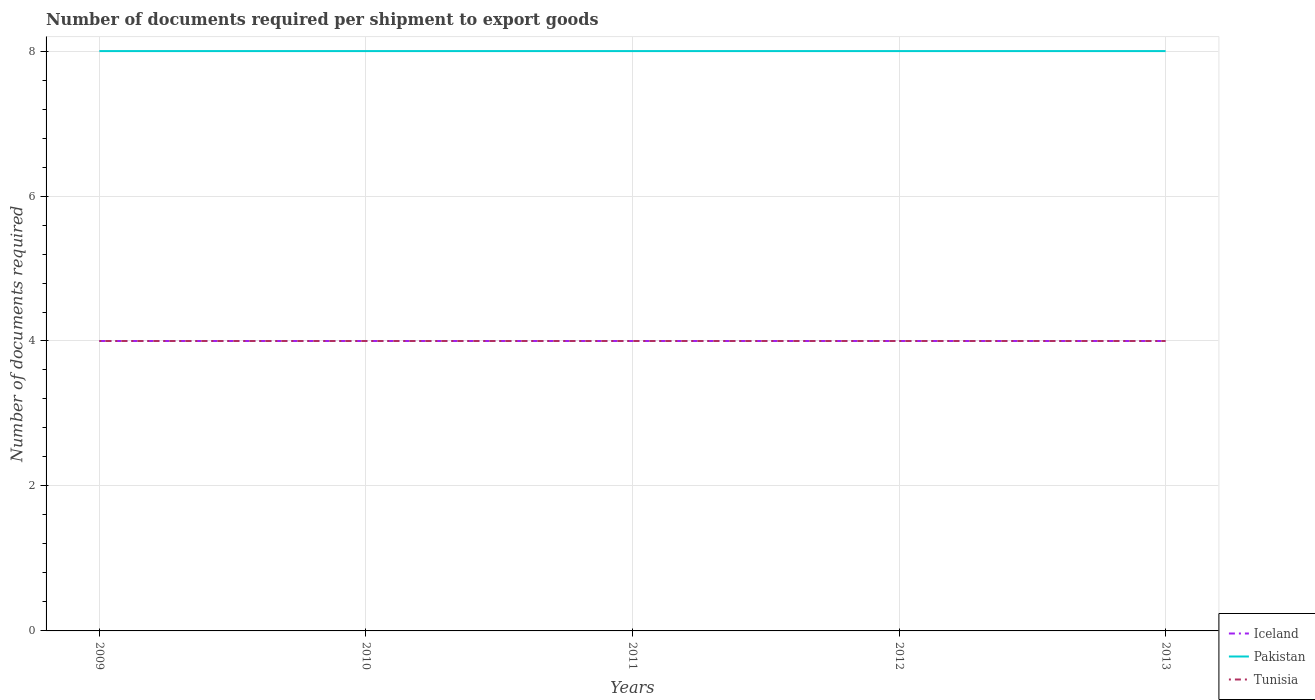How many different coloured lines are there?
Provide a succinct answer. 3. Across all years, what is the maximum number of documents required per shipment to export goods in Tunisia?
Offer a very short reply. 4. What is the difference between the highest and the second highest number of documents required per shipment to export goods in Pakistan?
Provide a succinct answer. 0. What is the difference between the highest and the lowest number of documents required per shipment to export goods in Tunisia?
Keep it short and to the point. 0. How many legend labels are there?
Make the answer very short. 3. How are the legend labels stacked?
Ensure brevity in your answer.  Vertical. What is the title of the graph?
Keep it short and to the point. Number of documents required per shipment to export goods. What is the label or title of the X-axis?
Your answer should be very brief. Years. What is the label or title of the Y-axis?
Provide a short and direct response. Number of documents required. What is the Number of documents required of Tunisia in 2009?
Provide a short and direct response. 4. What is the Number of documents required of Iceland in 2010?
Provide a succinct answer. 4. What is the Number of documents required of Pakistan in 2010?
Your answer should be compact. 8. What is the Number of documents required of Tunisia in 2010?
Ensure brevity in your answer.  4. What is the Number of documents required of Iceland in 2011?
Offer a terse response. 4. What is the Number of documents required of Pakistan in 2012?
Provide a succinct answer. 8. What is the Number of documents required in Tunisia in 2012?
Provide a short and direct response. 4. What is the Number of documents required of Tunisia in 2013?
Your answer should be compact. 4. Across all years, what is the maximum Number of documents required of Tunisia?
Offer a very short reply. 4. What is the difference between the Number of documents required of Iceland in 2009 and that in 2010?
Your response must be concise. 0. What is the difference between the Number of documents required in Pakistan in 2009 and that in 2010?
Your response must be concise. 0. What is the difference between the Number of documents required of Tunisia in 2009 and that in 2010?
Make the answer very short. 0. What is the difference between the Number of documents required in Pakistan in 2009 and that in 2012?
Offer a terse response. 0. What is the difference between the Number of documents required of Tunisia in 2009 and that in 2012?
Give a very brief answer. 0. What is the difference between the Number of documents required of Iceland in 2009 and that in 2013?
Make the answer very short. 0. What is the difference between the Number of documents required of Pakistan in 2009 and that in 2013?
Provide a short and direct response. 0. What is the difference between the Number of documents required of Iceland in 2010 and that in 2011?
Provide a succinct answer. 0. What is the difference between the Number of documents required in Tunisia in 2010 and that in 2011?
Provide a succinct answer. 0. What is the difference between the Number of documents required in Pakistan in 2010 and that in 2012?
Your answer should be compact. 0. What is the difference between the Number of documents required in Tunisia in 2010 and that in 2013?
Make the answer very short. 0. What is the difference between the Number of documents required in Iceland in 2011 and that in 2012?
Offer a terse response. 0. What is the difference between the Number of documents required in Pakistan in 2011 and that in 2012?
Keep it short and to the point. 0. What is the difference between the Number of documents required of Tunisia in 2011 and that in 2012?
Provide a short and direct response. 0. What is the difference between the Number of documents required of Iceland in 2011 and that in 2013?
Give a very brief answer. 0. What is the difference between the Number of documents required in Iceland in 2012 and that in 2013?
Keep it short and to the point. 0. What is the difference between the Number of documents required in Pakistan in 2012 and that in 2013?
Offer a very short reply. 0. What is the difference between the Number of documents required in Iceland in 2009 and the Number of documents required in Pakistan in 2010?
Keep it short and to the point. -4. What is the difference between the Number of documents required in Iceland in 2009 and the Number of documents required in Tunisia in 2010?
Your answer should be compact. 0. What is the difference between the Number of documents required of Iceland in 2009 and the Number of documents required of Pakistan in 2011?
Your answer should be compact. -4. What is the difference between the Number of documents required in Iceland in 2009 and the Number of documents required in Tunisia in 2011?
Your response must be concise. 0. What is the difference between the Number of documents required of Pakistan in 2009 and the Number of documents required of Tunisia in 2011?
Offer a terse response. 4. What is the difference between the Number of documents required in Iceland in 2009 and the Number of documents required in Pakistan in 2012?
Keep it short and to the point. -4. What is the difference between the Number of documents required in Iceland in 2009 and the Number of documents required in Pakistan in 2013?
Your answer should be very brief. -4. What is the difference between the Number of documents required of Iceland in 2010 and the Number of documents required of Pakistan in 2011?
Make the answer very short. -4. What is the difference between the Number of documents required of Pakistan in 2010 and the Number of documents required of Tunisia in 2011?
Make the answer very short. 4. What is the difference between the Number of documents required in Iceland in 2010 and the Number of documents required in Tunisia in 2013?
Your response must be concise. 0. What is the difference between the Number of documents required of Iceland in 2011 and the Number of documents required of Pakistan in 2012?
Give a very brief answer. -4. What is the difference between the Number of documents required in Iceland in 2011 and the Number of documents required in Tunisia in 2012?
Make the answer very short. 0. What is the difference between the Number of documents required of Pakistan in 2011 and the Number of documents required of Tunisia in 2013?
Your answer should be very brief. 4. What is the difference between the Number of documents required of Iceland in 2012 and the Number of documents required of Pakistan in 2013?
Your response must be concise. -4. What is the difference between the Number of documents required of Iceland in 2012 and the Number of documents required of Tunisia in 2013?
Keep it short and to the point. 0. What is the average Number of documents required in Pakistan per year?
Your answer should be very brief. 8. In the year 2009, what is the difference between the Number of documents required in Iceland and Number of documents required in Pakistan?
Your answer should be very brief. -4. In the year 2009, what is the difference between the Number of documents required in Iceland and Number of documents required in Tunisia?
Your answer should be compact. 0. In the year 2010, what is the difference between the Number of documents required of Iceland and Number of documents required of Pakistan?
Keep it short and to the point. -4. In the year 2010, what is the difference between the Number of documents required of Iceland and Number of documents required of Tunisia?
Make the answer very short. 0. In the year 2010, what is the difference between the Number of documents required of Pakistan and Number of documents required of Tunisia?
Ensure brevity in your answer.  4. In the year 2011, what is the difference between the Number of documents required in Iceland and Number of documents required in Tunisia?
Ensure brevity in your answer.  0. In the year 2012, what is the difference between the Number of documents required in Pakistan and Number of documents required in Tunisia?
Keep it short and to the point. 4. In the year 2013, what is the difference between the Number of documents required of Iceland and Number of documents required of Pakistan?
Provide a short and direct response. -4. In the year 2013, what is the difference between the Number of documents required of Iceland and Number of documents required of Tunisia?
Provide a short and direct response. 0. What is the ratio of the Number of documents required in Pakistan in 2009 to that in 2011?
Make the answer very short. 1. What is the ratio of the Number of documents required of Iceland in 2009 to that in 2012?
Your answer should be very brief. 1. What is the ratio of the Number of documents required of Tunisia in 2009 to that in 2012?
Offer a terse response. 1. What is the ratio of the Number of documents required of Iceland in 2009 to that in 2013?
Offer a terse response. 1. What is the ratio of the Number of documents required in Pakistan in 2009 to that in 2013?
Keep it short and to the point. 1. What is the ratio of the Number of documents required of Iceland in 2010 to that in 2011?
Your answer should be compact. 1. What is the ratio of the Number of documents required of Tunisia in 2010 to that in 2011?
Provide a succinct answer. 1. What is the ratio of the Number of documents required in Iceland in 2010 to that in 2012?
Give a very brief answer. 1. What is the ratio of the Number of documents required of Pakistan in 2010 to that in 2012?
Provide a succinct answer. 1. What is the ratio of the Number of documents required in Tunisia in 2010 to that in 2012?
Provide a succinct answer. 1. What is the ratio of the Number of documents required of Pakistan in 2010 to that in 2013?
Offer a very short reply. 1. What is the ratio of the Number of documents required of Tunisia in 2010 to that in 2013?
Your answer should be very brief. 1. What is the ratio of the Number of documents required of Iceland in 2011 to that in 2012?
Your answer should be compact. 1. What is the ratio of the Number of documents required in Pakistan in 2011 to that in 2012?
Provide a short and direct response. 1. What is the ratio of the Number of documents required in Tunisia in 2011 to that in 2012?
Provide a succinct answer. 1. What is the ratio of the Number of documents required of Tunisia in 2011 to that in 2013?
Provide a short and direct response. 1. What is the difference between the highest and the second highest Number of documents required of Iceland?
Offer a terse response. 0. 